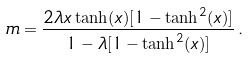<formula> <loc_0><loc_0><loc_500><loc_500>m = \frac { 2 \lambda x \tanh ( x ) [ 1 - \tanh ^ { 2 } ( x ) ] } { 1 - \lambda [ 1 - \tanh ^ { 2 } ( x ) ] } \, .</formula> 